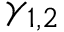Convert formula to latex. <formula><loc_0><loc_0><loc_500><loc_500>\gamma _ { 1 , 2 }</formula> 